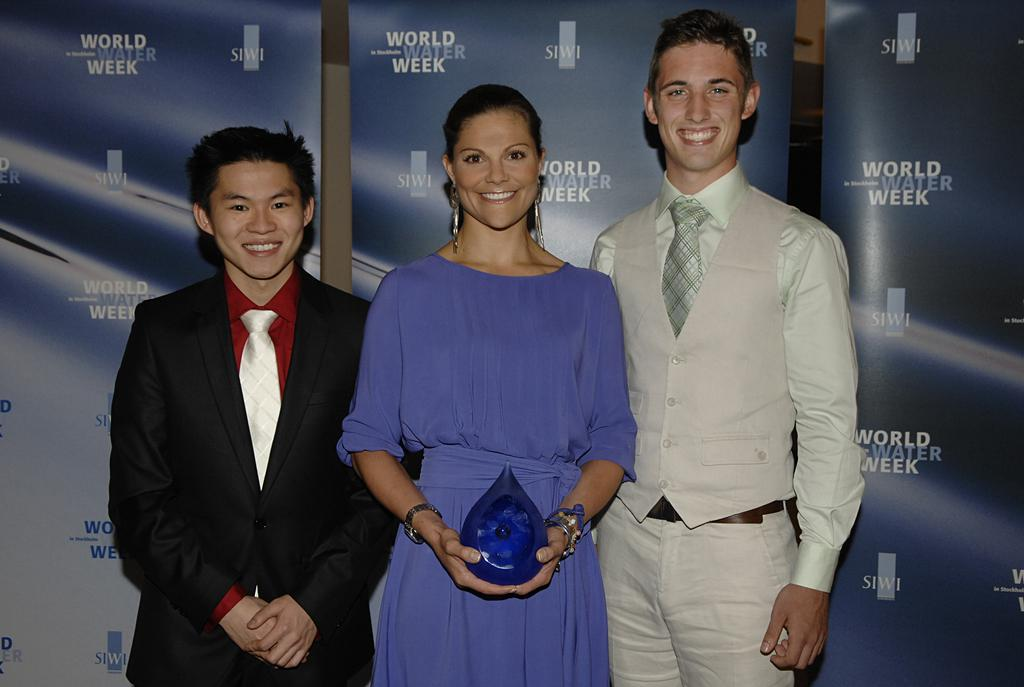How many people are in the image? There are three persons in the image. What are the persons doing in the image? The persons are standing and smiling. What can be seen in the background of the image? There are boards in the background of the image. What type of banana can be seen in the image? There is no banana present in the image. 